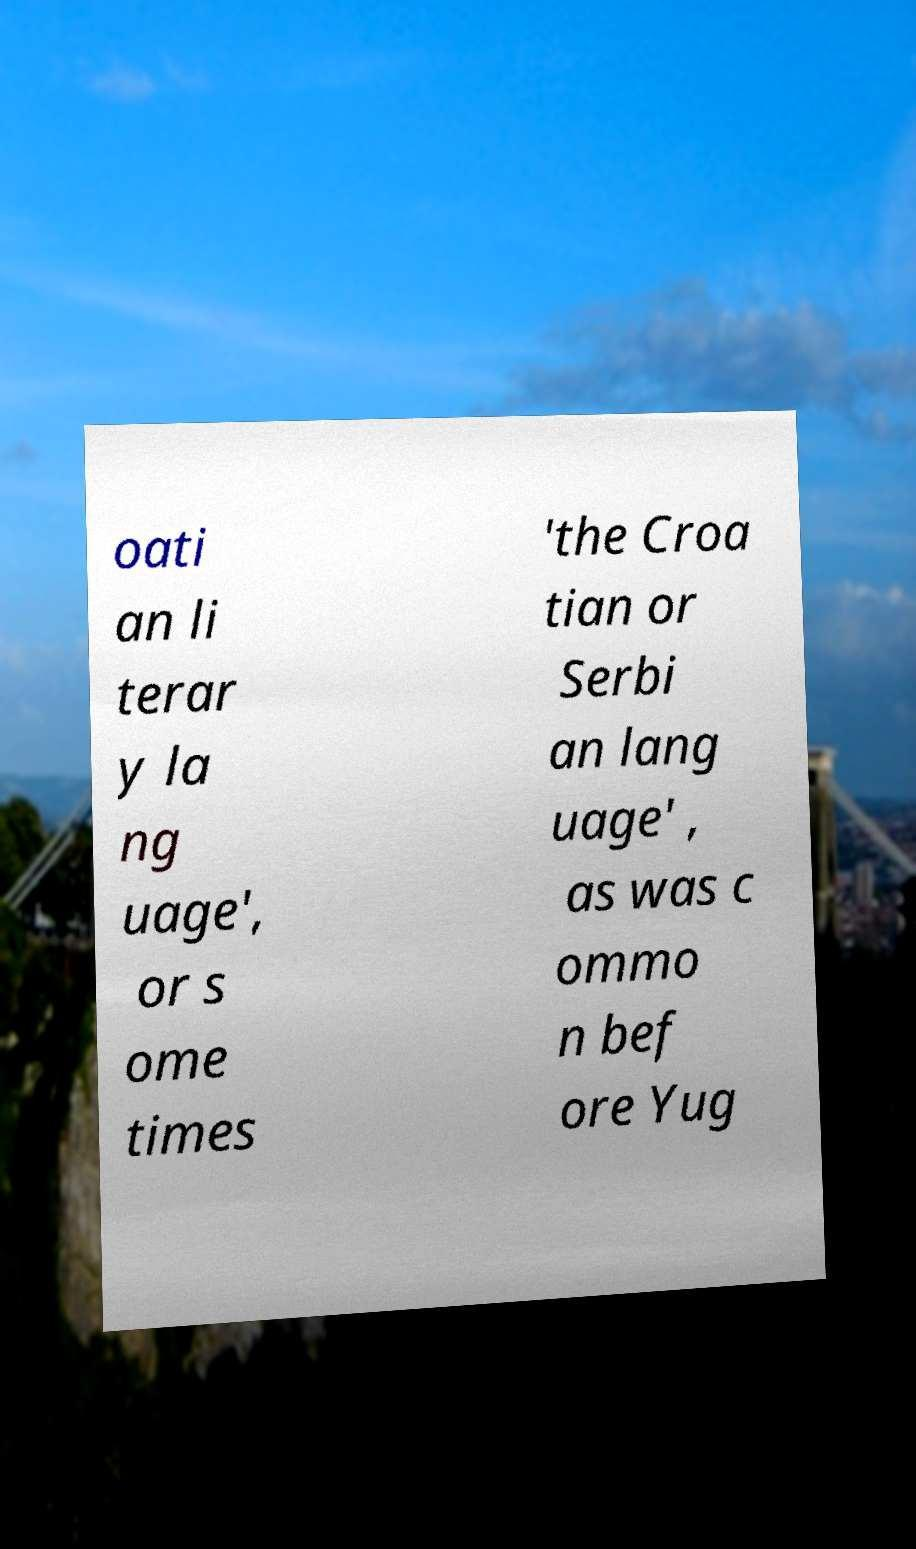Could you extract and type out the text from this image? oati an li terar y la ng uage', or s ome times 'the Croa tian or Serbi an lang uage' , as was c ommo n bef ore Yug 